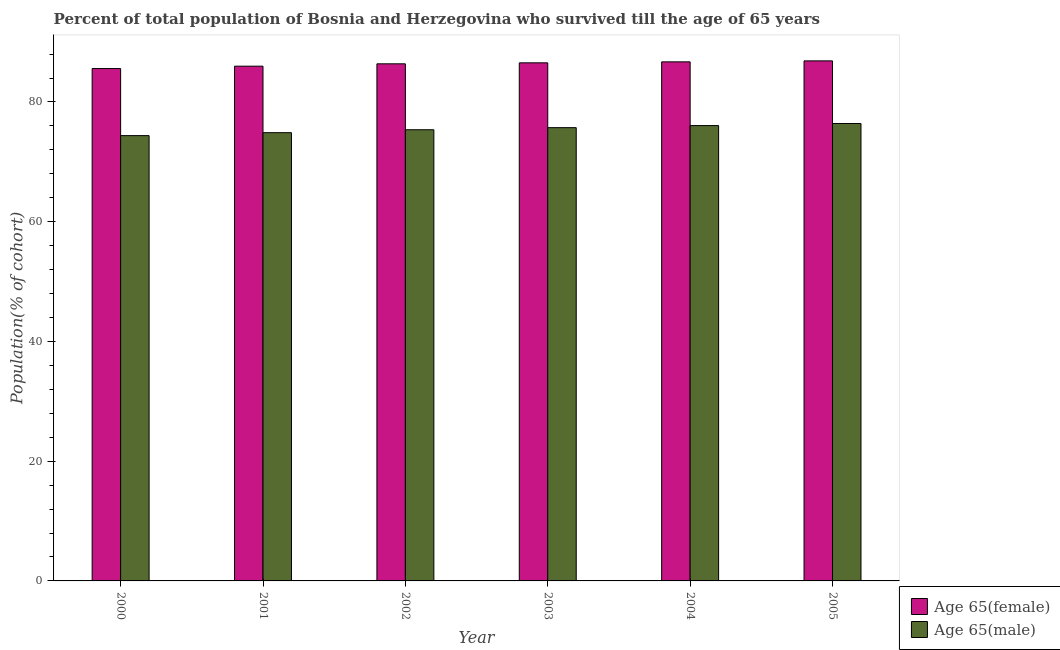How many different coloured bars are there?
Offer a very short reply. 2. Are the number of bars per tick equal to the number of legend labels?
Your response must be concise. Yes. Are the number of bars on each tick of the X-axis equal?
Give a very brief answer. Yes. How many bars are there on the 4th tick from the left?
Your answer should be compact. 2. What is the percentage of female population who survived till age of 65 in 2005?
Your response must be concise. 86.87. Across all years, what is the maximum percentage of male population who survived till age of 65?
Keep it short and to the point. 76.41. Across all years, what is the minimum percentage of female population who survived till age of 65?
Make the answer very short. 85.58. What is the total percentage of female population who survived till age of 65 in the graph?
Provide a short and direct response. 518.05. What is the difference between the percentage of female population who survived till age of 65 in 2000 and that in 2001?
Your answer should be very brief. -0.4. What is the difference between the percentage of male population who survived till age of 65 in 2001 and the percentage of female population who survived till age of 65 in 2002?
Give a very brief answer. -0.49. What is the average percentage of female population who survived till age of 65 per year?
Give a very brief answer. 86.34. What is the ratio of the percentage of female population who survived till age of 65 in 2003 to that in 2005?
Make the answer very short. 1. Is the percentage of female population who survived till age of 65 in 2000 less than that in 2001?
Keep it short and to the point. Yes. What is the difference between the highest and the second highest percentage of female population who survived till age of 65?
Provide a succinct answer. 0.16. What is the difference between the highest and the lowest percentage of female population who survived till age of 65?
Give a very brief answer. 1.28. In how many years, is the percentage of female population who survived till age of 65 greater than the average percentage of female population who survived till age of 65 taken over all years?
Ensure brevity in your answer.  4. What does the 1st bar from the left in 2002 represents?
Ensure brevity in your answer.  Age 65(female). What does the 1st bar from the right in 2005 represents?
Your response must be concise. Age 65(male). How many bars are there?
Provide a succinct answer. 12. How many years are there in the graph?
Ensure brevity in your answer.  6. Are the values on the major ticks of Y-axis written in scientific E-notation?
Offer a terse response. No. Does the graph contain grids?
Your answer should be compact. No. How many legend labels are there?
Provide a short and direct response. 2. How are the legend labels stacked?
Provide a short and direct response. Vertical. What is the title of the graph?
Provide a short and direct response. Percent of total population of Bosnia and Herzegovina who survived till the age of 65 years. What is the label or title of the X-axis?
Keep it short and to the point. Year. What is the label or title of the Y-axis?
Your answer should be very brief. Population(% of cohort). What is the Population(% of cohort) of Age 65(female) in 2000?
Your answer should be compact. 85.58. What is the Population(% of cohort) in Age 65(male) in 2000?
Your answer should be compact. 74.38. What is the Population(% of cohort) in Age 65(female) in 2001?
Keep it short and to the point. 85.98. What is the Population(% of cohort) of Age 65(male) in 2001?
Keep it short and to the point. 74.87. What is the Population(% of cohort) in Age 65(female) in 2002?
Provide a short and direct response. 86.38. What is the Population(% of cohort) of Age 65(male) in 2002?
Offer a very short reply. 75.36. What is the Population(% of cohort) of Age 65(female) in 2003?
Make the answer very short. 86.54. What is the Population(% of cohort) of Age 65(male) in 2003?
Provide a succinct answer. 75.71. What is the Population(% of cohort) in Age 65(female) in 2004?
Keep it short and to the point. 86.7. What is the Population(% of cohort) in Age 65(male) in 2004?
Offer a terse response. 76.06. What is the Population(% of cohort) in Age 65(female) in 2005?
Provide a short and direct response. 86.87. What is the Population(% of cohort) of Age 65(male) in 2005?
Make the answer very short. 76.41. Across all years, what is the maximum Population(% of cohort) in Age 65(female)?
Your answer should be very brief. 86.87. Across all years, what is the maximum Population(% of cohort) of Age 65(male)?
Your answer should be very brief. 76.41. Across all years, what is the minimum Population(% of cohort) of Age 65(female)?
Keep it short and to the point. 85.58. Across all years, what is the minimum Population(% of cohort) in Age 65(male)?
Offer a terse response. 74.38. What is the total Population(% of cohort) in Age 65(female) in the graph?
Keep it short and to the point. 518.05. What is the total Population(% of cohort) of Age 65(male) in the graph?
Keep it short and to the point. 452.79. What is the difference between the Population(% of cohort) of Age 65(female) in 2000 and that in 2001?
Provide a succinct answer. -0.4. What is the difference between the Population(% of cohort) of Age 65(male) in 2000 and that in 2001?
Offer a terse response. -0.49. What is the difference between the Population(% of cohort) in Age 65(female) in 2000 and that in 2002?
Your answer should be compact. -0.79. What is the difference between the Population(% of cohort) of Age 65(male) in 2000 and that in 2002?
Your answer should be very brief. -0.98. What is the difference between the Population(% of cohort) in Age 65(female) in 2000 and that in 2003?
Make the answer very short. -0.95. What is the difference between the Population(% of cohort) in Age 65(male) in 2000 and that in 2003?
Your answer should be very brief. -1.33. What is the difference between the Population(% of cohort) in Age 65(female) in 2000 and that in 2004?
Give a very brief answer. -1.12. What is the difference between the Population(% of cohort) of Age 65(male) in 2000 and that in 2004?
Keep it short and to the point. -1.68. What is the difference between the Population(% of cohort) in Age 65(female) in 2000 and that in 2005?
Your answer should be very brief. -1.28. What is the difference between the Population(% of cohort) in Age 65(male) in 2000 and that in 2005?
Ensure brevity in your answer.  -2.02. What is the difference between the Population(% of cohort) in Age 65(female) in 2001 and that in 2002?
Keep it short and to the point. -0.4. What is the difference between the Population(% of cohort) of Age 65(male) in 2001 and that in 2002?
Keep it short and to the point. -0.49. What is the difference between the Population(% of cohort) in Age 65(female) in 2001 and that in 2003?
Make the answer very short. -0.56. What is the difference between the Population(% of cohort) of Age 65(male) in 2001 and that in 2003?
Provide a short and direct response. -0.84. What is the difference between the Population(% of cohort) of Age 65(female) in 2001 and that in 2004?
Provide a succinct answer. -0.72. What is the difference between the Population(% of cohort) in Age 65(male) in 2001 and that in 2004?
Offer a terse response. -1.19. What is the difference between the Population(% of cohort) in Age 65(female) in 2001 and that in 2005?
Ensure brevity in your answer.  -0.89. What is the difference between the Population(% of cohort) in Age 65(male) in 2001 and that in 2005?
Keep it short and to the point. -1.53. What is the difference between the Population(% of cohort) of Age 65(female) in 2002 and that in 2003?
Keep it short and to the point. -0.16. What is the difference between the Population(% of cohort) in Age 65(male) in 2002 and that in 2003?
Your answer should be very brief. -0.35. What is the difference between the Population(% of cohort) in Age 65(female) in 2002 and that in 2004?
Make the answer very short. -0.33. What is the difference between the Population(% of cohort) of Age 65(male) in 2002 and that in 2004?
Ensure brevity in your answer.  -0.7. What is the difference between the Population(% of cohort) in Age 65(female) in 2002 and that in 2005?
Offer a very short reply. -0.49. What is the difference between the Population(% of cohort) in Age 65(male) in 2002 and that in 2005?
Provide a short and direct response. -1.04. What is the difference between the Population(% of cohort) of Age 65(female) in 2003 and that in 2004?
Make the answer very short. -0.16. What is the difference between the Population(% of cohort) of Age 65(male) in 2003 and that in 2004?
Ensure brevity in your answer.  -0.35. What is the difference between the Population(% of cohort) of Age 65(female) in 2003 and that in 2005?
Keep it short and to the point. -0.33. What is the difference between the Population(% of cohort) of Age 65(male) in 2003 and that in 2005?
Offer a very short reply. -0.7. What is the difference between the Population(% of cohort) in Age 65(female) in 2004 and that in 2005?
Ensure brevity in your answer.  -0.16. What is the difference between the Population(% of cohort) of Age 65(male) in 2004 and that in 2005?
Offer a terse response. -0.35. What is the difference between the Population(% of cohort) of Age 65(female) in 2000 and the Population(% of cohort) of Age 65(male) in 2001?
Your response must be concise. 10.71. What is the difference between the Population(% of cohort) of Age 65(female) in 2000 and the Population(% of cohort) of Age 65(male) in 2002?
Provide a short and direct response. 10.22. What is the difference between the Population(% of cohort) of Age 65(female) in 2000 and the Population(% of cohort) of Age 65(male) in 2003?
Your answer should be compact. 9.87. What is the difference between the Population(% of cohort) of Age 65(female) in 2000 and the Population(% of cohort) of Age 65(male) in 2004?
Your response must be concise. 9.53. What is the difference between the Population(% of cohort) in Age 65(female) in 2000 and the Population(% of cohort) in Age 65(male) in 2005?
Give a very brief answer. 9.18. What is the difference between the Population(% of cohort) of Age 65(female) in 2001 and the Population(% of cohort) of Age 65(male) in 2002?
Your response must be concise. 10.62. What is the difference between the Population(% of cohort) in Age 65(female) in 2001 and the Population(% of cohort) in Age 65(male) in 2003?
Ensure brevity in your answer.  10.27. What is the difference between the Population(% of cohort) of Age 65(female) in 2001 and the Population(% of cohort) of Age 65(male) in 2004?
Provide a short and direct response. 9.92. What is the difference between the Population(% of cohort) in Age 65(female) in 2001 and the Population(% of cohort) in Age 65(male) in 2005?
Ensure brevity in your answer.  9.57. What is the difference between the Population(% of cohort) in Age 65(female) in 2002 and the Population(% of cohort) in Age 65(male) in 2003?
Offer a terse response. 10.66. What is the difference between the Population(% of cohort) in Age 65(female) in 2002 and the Population(% of cohort) in Age 65(male) in 2004?
Offer a terse response. 10.32. What is the difference between the Population(% of cohort) in Age 65(female) in 2002 and the Population(% of cohort) in Age 65(male) in 2005?
Provide a short and direct response. 9.97. What is the difference between the Population(% of cohort) of Age 65(female) in 2003 and the Population(% of cohort) of Age 65(male) in 2004?
Your answer should be very brief. 10.48. What is the difference between the Population(% of cohort) of Age 65(female) in 2003 and the Population(% of cohort) of Age 65(male) in 2005?
Provide a short and direct response. 10.13. What is the difference between the Population(% of cohort) of Age 65(female) in 2004 and the Population(% of cohort) of Age 65(male) in 2005?
Ensure brevity in your answer.  10.3. What is the average Population(% of cohort) in Age 65(female) per year?
Keep it short and to the point. 86.34. What is the average Population(% of cohort) of Age 65(male) per year?
Your answer should be compact. 75.47. In the year 2000, what is the difference between the Population(% of cohort) of Age 65(female) and Population(% of cohort) of Age 65(male)?
Offer a very short reply. 11.2. In the year 2001, what is the difference between the Population(% of cohort) of Age 65(female) and Population(% of cohort) of Age 65(male)?
Provide a succinct answer. 11.11. In the year 2002, what is the difference between the Population(% of cohort) in Age 65(female) and Population(% of cohort) in Age 65(male)?
Give a very brief answer. 11.01. In the year 2003, what is the difference between the Population(% of cohort) in Age 65(female) and Population(% of cohort) in Age 65(male)?
Provide a succinct answer. 10.83. In the year 2004, what is the difference between the Population(% of cohort) of Age 65(female) and Population(% of cohort) of Age 65(male)?
Keep it short and to the point. 10.64. In the year 2005, what is the difference between the Population(% of cohort) in Age 65(female) and Population(% of cohort) in Age 65(male)?
Keep it short and to the point. 10.46. What is the ratio of the Population(% of cohort) of Age 65(male) in 2000 to that in 2002?
Provide a succinct answer. 0.99. What is the ratio of the Population(% of cohort) of Age 65(female) in 2000 to that in 2003?
Ensure brevity in your answer.  0.99. What is the ratio of the Population(% of cohort) in Age 65(male) in 2000 to that in 2003?
Ensure brevity in your answer.  0.98. What is the ratio of the Population(% of cohort) in Age 65(female) in 2000 to that in 2004?
Make the answer very short. 0.99. What is the ratio of the Population(% of cohort) in Age 65(male) in 2000 to that in 2004?
Make the answer very short. 0.98. What is the ratio of the Population(% of cohort) of Age 65(female) in 2000 to that in 2005?
Provide a succinct answer. 0.99. What is the ratio of the Population(% of cohort) of Age 65(male) in 2000 to that in 2005?
Your answer should be compact. 0.97. What is the ratio of the Population(% of cohort) in Age 65(male) in 2001 to that in 2002?
Offer a terse response. 0.99. What is the ratio of the Population(% of cohort) of Age 65(female) in 2001 to that in 2003?
Provide a short and direct response. 0.99. What is the ratio of the Population(% of cohort) of Age 65(male) in 2001 to that in 2003?
Provide a short and direct response. 0.99. What is the ratio of the Population(% of cohort) of Age 65(male) in 2001 to that in 2004?
Provide a short and direct response. 0.98. What is the ratio of the Population(% of cohort) in Age 65(female) in 2001 to that in 2005?
Your response must be concise. 0.99. What is the ratio of the Population(% of cohort) of Age 65(male) in 2001 to that in 2005?
Give a very brief answer. 0.98. What is the ratio of the Population(% of cohort) of Age 65(female) in 2002 to that in 2003?
Offer a terse response. 1. What is the ratio of the Population(% of cohort) in Age 65(male) in 2002 to that in 2003?
Provide a succinct answer. 1. What is the ratio of the Population(% of cohort) of Age 65(male) in 2002 to that in 2004?
Give a very brief answer. 0.99. What is the ratio of the Population(% of cohort) of Age 65(female) in 2002 to that in 2005?
Give a very brief answer. 0.99. What is the ratio of the Population(% of cohort) in Age 65(male) in 2002 to that in 2005?
Make the answer very short. 0.99. What is the ratio of the Population(% of cohort) of Age 65(female) in 2003 to that in 2005?
Provide a short and direct response. 1. What is the ratio of the Population(% of cohort) of Age 65(male) in 2003 to that in 2005?
Make the answer very short. 0.99. What is the ratio of the Population(% of cohort) of Age 65(female) in 2004 to that in 2005?
Your response must be concise. 1. What is the difference between the highest and the second highest Population(% of cohort) of Age 65(female)?
Provide a short and direct response. 0.16. What is the difference between the highest and the second highest Population(% of cohort) of Age 65(male)?
Offer a very short reply. 0.35. What is the difference between the highest and the lowest Population(% of cohort) of Age 65(female)?
Offer a very short reply. 1.28. What is the difference between the highest and the lowest Population(% of cohort) in Age 65(male)?
Offer a very short reply. 2.02. 